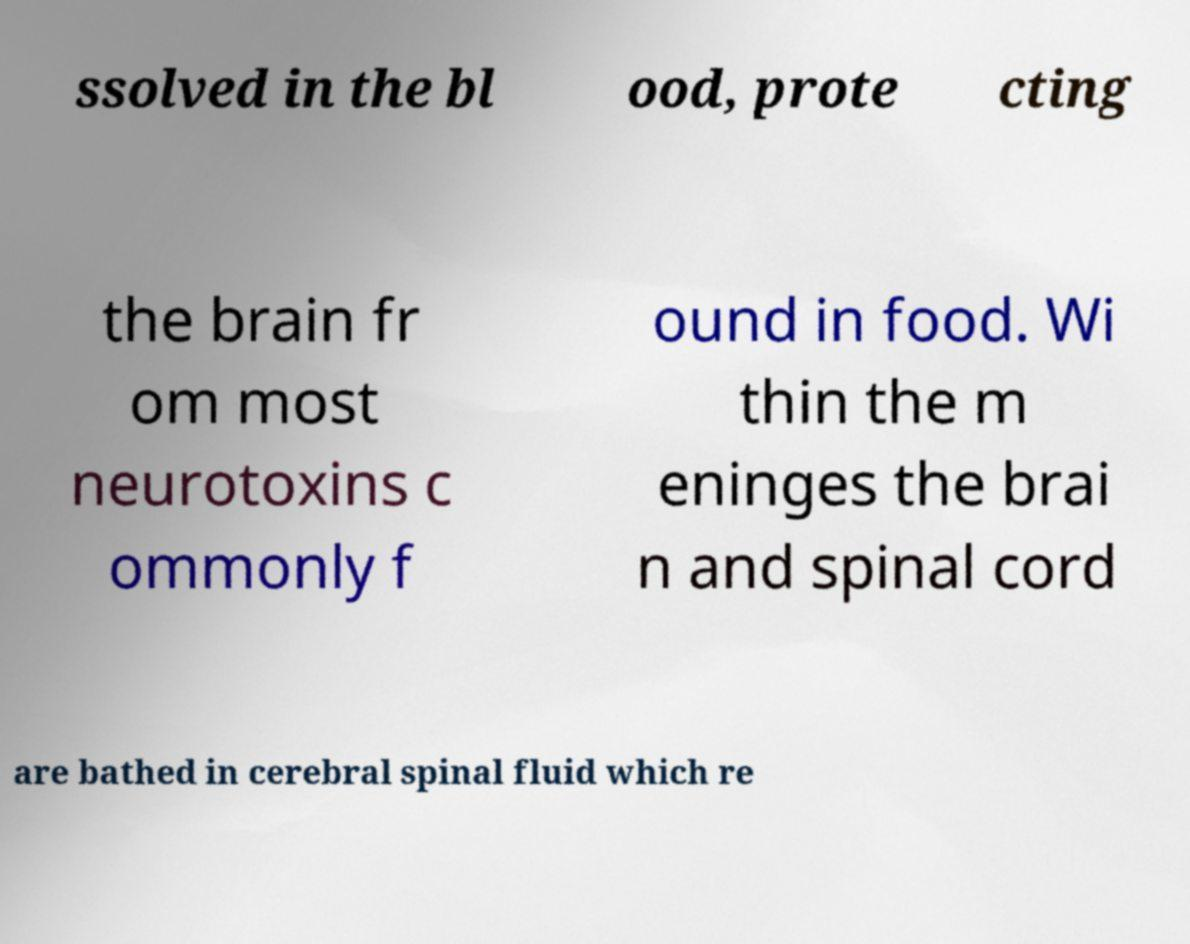Can you read and provide the text displayed in the image?This photo seems to have some interesting text. Can you extract and type it out for me? ssolved in the bl ood, prote cting the brain fr om most neurotoxins c ommonly f ound in food. Wi thin the m eninges the brai n and spinal cord are bathed in cerebral spinal fluid which re 